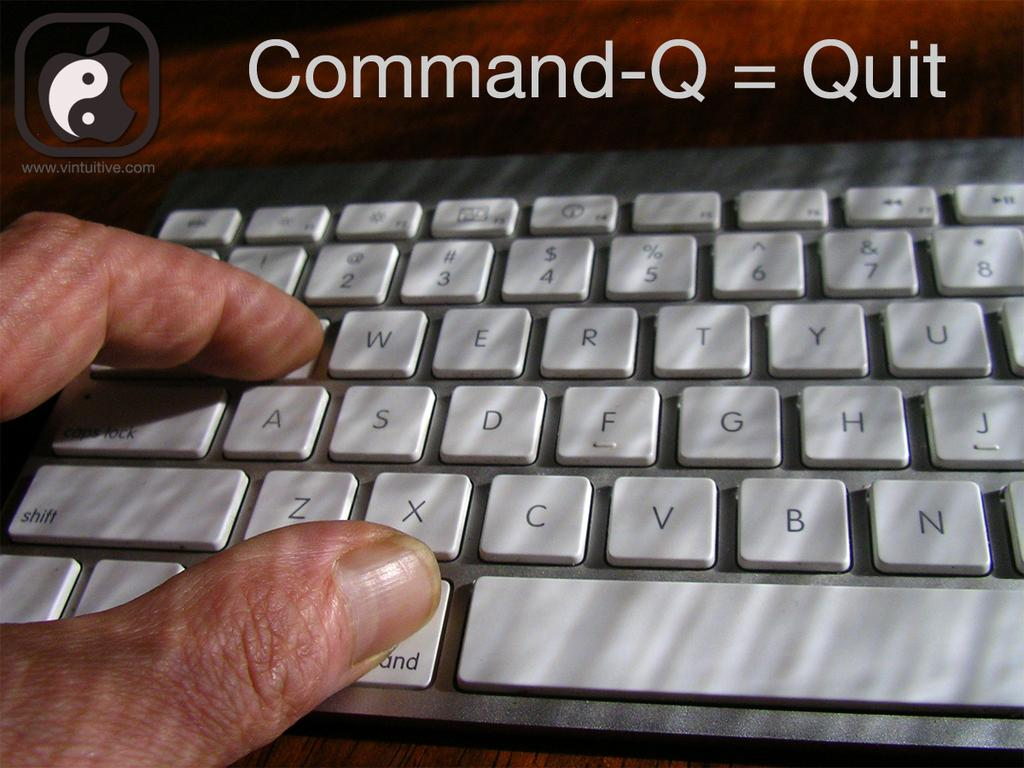<image>
Create a compact narrative representing the image presented. The instructions for the command to quit are shown above a keyboard with fingers on the command and q buttons. 